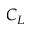<formula> <loc_0><loc_0><loc_500><loc_500>C _ { L }</formula> 